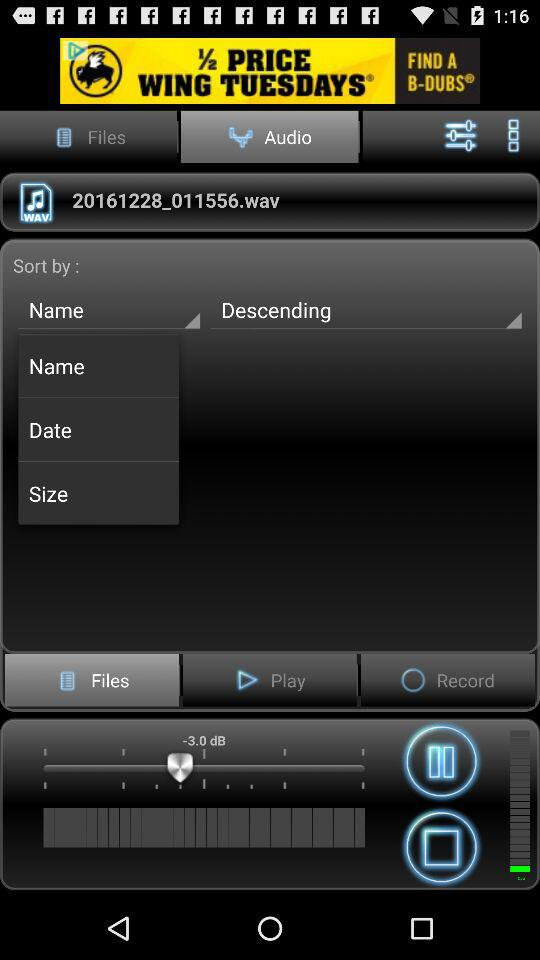Which files are there to choose from?
When the provided information is insufficient, respond with <no answer>. <no answer> 